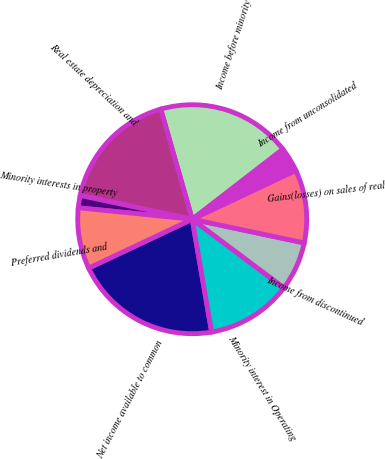Convert chart. <chart><loc_0><loc_0><loc_500><loc_500><pie_chart><fcel>Net income available to common<fcel>Minority interest in Operating<fcel>Income from discontinued<fcel>Gains(losses) on sales of real<fcel>Income from unconsolidated<fcel>Income before minority<fcel>Real estate depreciation and<fcel>Minority interests in property<fcel>Preferred dividends and<nl><fcel>20.69%<fcel>12.07%<fcel>6.9%<fcel>10.35%<fcel>3.45%<fcel>18.96%<fcel>17.24%<fcel>1.73%<fcel>8.62%<nl></chart> 